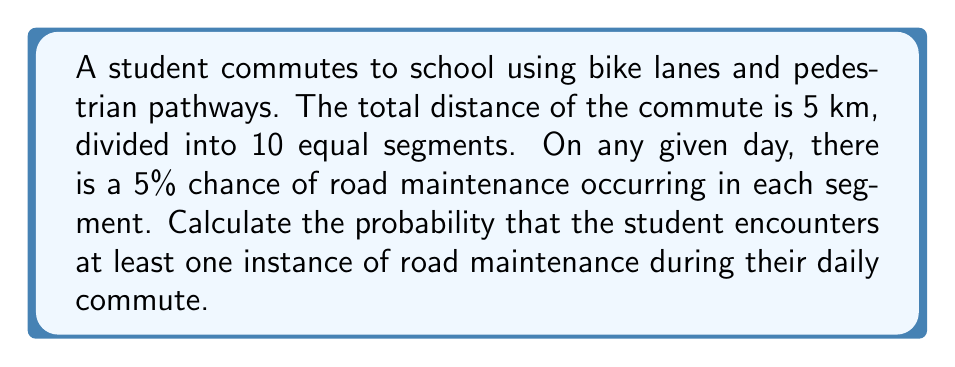Give your solution to this math problem. Let's approach this step-by-step:

1) First, we need to calculate the probability of not encountering road maintenance in a single segment:
   $P(\text{no maintenance in one segment}) = 1 - 0.05 = 0.95$

2) For the entire commute to be free of road maintenance, all 10 segments must be free of maintenance. Since the events are independent, we multiply the probabilities:
   $P(\text{no maintenance in entire commute}) = 0.95^{10}$

3) We can calculate this:
   $0.95^{10} \approx 0.5987$

4) The probability of encountering at least one instance of road maintenance is the complement of having no maintenance:
   $P(\text{at least one maintenance}) = 1 - P(\text{no maintenance in entire commute})$

5) Therefore:
   $P(\text{at least one maintenance}) = 1 - 0.5987 \approx 0.4013$

6) Converting to a percentage:
   $0.4013 \times 100\% \approx 40.13\%$
Answer: 40.13% 